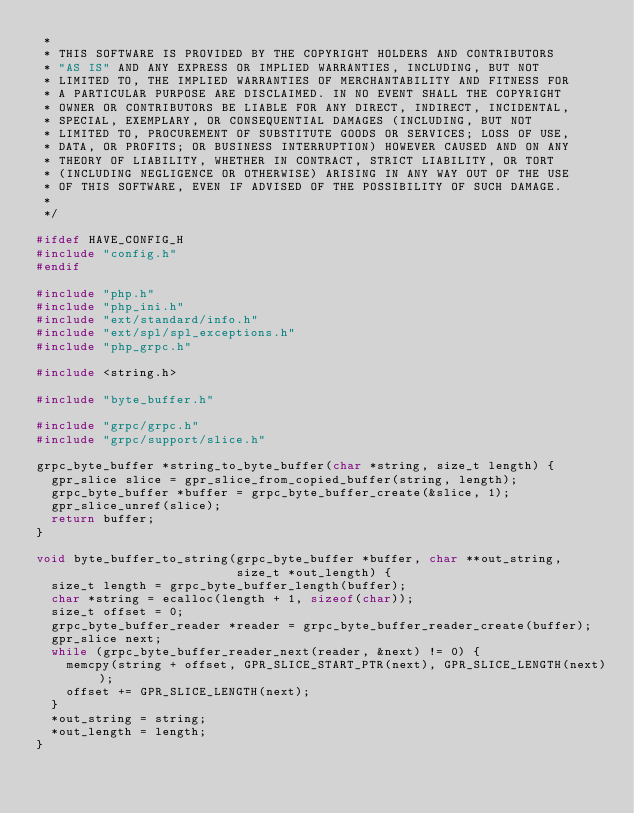<code> <loc_0><loc_0><loc_500><loc_500><_C_> *
 * THIS SOFTWARE IS PROVIDED BY THE COPYRIGHT HOLDERS AND CONTRIBUTORS
 * "AS IS" AND ANY EXPRESS OR IMPLIED WARRANTIES, INCLUDING, BUT NOT
 * LIMITED TO, THE IMPLIED WARRANTIES OF MERCHANTABILITY AND FITNESS FOR
 * A PARTICULAR PURPOSE ARE DISCLAIMED. IN NO EVENT SHALL THE COPYRIGHT
 * OWNER OR CONTRIBUTORS BE LIABLE FOR ANY DIRECT, INDIRECT, INCIDENTAL,
 * SPECIAL, EXEMPLARY, OR CONSEQUENTIAL DAMAGES (INCLUDING, BUT NOT
 * LIMITED TO, PROCUREMENT OF SUBSTITUTE GOODS OR SERVICES; LOSS OF USE,
 * DATA, OR PROFITS; OR BUSINESS INTERRUPTION) HOWEVER CAUSED AND ON ANY
 * THEORY OF LIABILITY, WHETHER IN CONTRACT, STRICT LIABILITY, OR TORT
 * (INCLUDING NEGLIGENCE OR OTHERWISE) ARISING IN ANY WAY OUT OF THE USE
 * OF THIS SOFTWARE, EVEN IF ADVISED OF THE POSSIBILITY OF SUCH DAMAGE.
 *
 */

#ifdef HAVE_CONFIG_H
#include "config.h"
#endif

#include "php.h"
#include "php_ini.h"
#include "ext/standard/info.h"
#include "ext/spl/spl_exceptions.h"
#include "php_grpc.h"

#include <string.h>

#include "byte_buffer.h"

#include "grpc/grpc.h"
#include "grpc/support/slice.h"

grpc_byte_buffer *string_to_byte_buffer(char *string, size_t length) {
  gpr_slice slice = gpr_slice_from_copied_buffer(string, length);
  grpc_byte_buffer *buffer = grpc_byte_buffer_create(&slice, 1);
  gpr_slice_unref(slice);
  return buffer;
}

void byte_buffer_to_string(grpc_byte_buffer *buffer, char **out_string,
                           size_t *out_length) {
  size_t length = grpc_byte_buffer_length(buffer);
  char *string = ecalloc(length + 1, sizeof(char));
  size_t offset = 0;
  grpc_byte_buffer_reader *reader = grpc_byte_buffer_reader_create(buffer);
  gpr_slice next;
  while (grpc_byte_buffer_reader_next(reader, &next) != 0) {
    memcpy(string + offset, GPR_SLICE_START_PTR(next), GPR_SLICE_LENGTH(next));
    offset += GPR_SLICE_LENGTH(next);
  }
  *out_string = string;
  *out_length = length;
}
</code> 